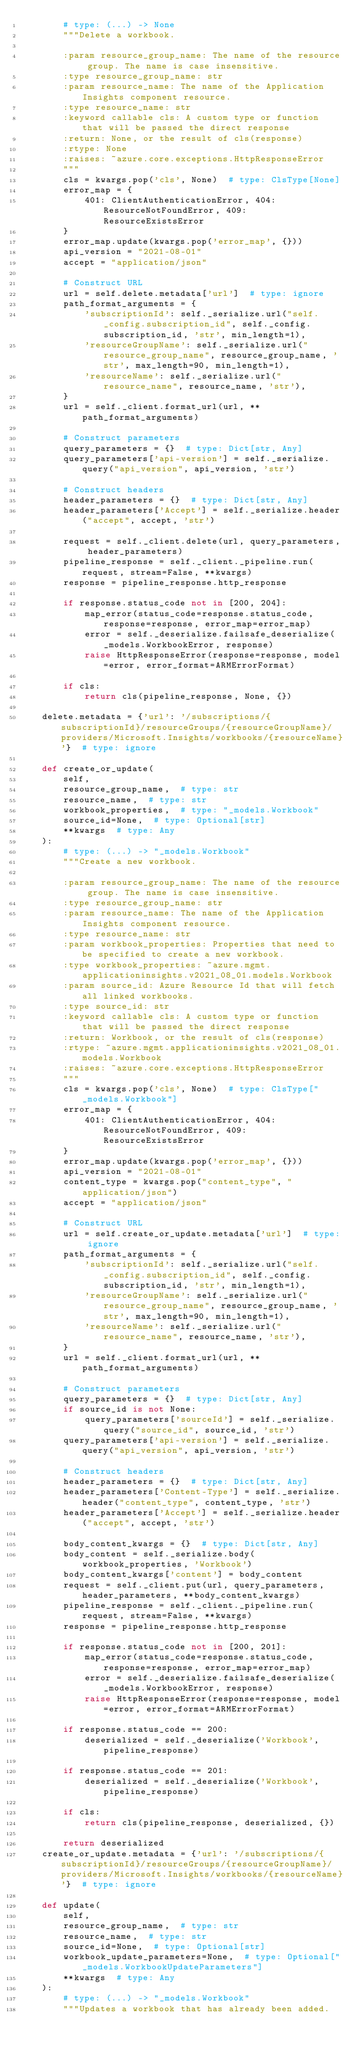Convert code to text. <code><loc_0><loc_0><loc_500><loc_500><_Python_>        # type: (...) -> None
        """Delete a workbook.

        :param resource_group_name: The name of the resource group. The name is case insensitive.
        :type resource_group_name: str
        :param resource_name: The name of the Application Insights component resource.
        :type resource_name: str
        :keyword callable cls: A custom type or function that will be passed the direct response
        :return: None, or the result of cls(response)
        :rtype: None
        :raises: ~azure.core.exceptions.HttpResponseError
        """
        cls = kwargs.pop('cls', None)  # type: ClsType[None]
        error_map = {
            401: ClientAuthenticationError, 404: ResourceNotFoundError, 409: ResourceExistsError
        }
        error_map.update(kwargs.pop('error_map', {}))
        api_version = "2021-08-01"
        accept = "application/json"

        # Construct URL
        url = self.delete.metadata['url']  # type: ignore
        path_format_arguments = {
            'subscriptionId': self._serialize.url("self._config.subscription_id", self._config.subscription_id, 'str', min_length=1),
            'resourceGroupName': self._serialize.url("resource_group_name", resource_group_name, 'str', max_length=90, min_length=1),
            'resourceName': self._serialize.url("resource_name", resource_name, 'str'),
        }
        url = self._client.format_url(url, **path_format_arguments)

        # Construct parameters
        query_parameters = {}  # type: Dict[str, Any]
        query_parameters['api-version'] = self._serialize.query("api_version", api_version, 'str')

        # Construct headers
        header_parameters = {}  # type: Dict[str, Any]
        header_parameters['Accept'] = self._serialize.header("accept", accept, 'str')

        request = self._client.delete(url, query_parameters, header_parameters)
        pipeline_response = self._client._pipeline.run(request, stream=False, **kwargs)
        response = pipeline_response.http_response

        if response.status_code not in [200, 204]:
            map_error(status_code=response.status_code, response=response, error_map=error_map)
            error = self._deserialize.failsafe_deserialize(_models.WorkbookError, response)
            raise HttpResponseError(response=response, model=error, error_format=ARMErrorFormat)

        if cls:
            return cls(pipeline_response, None, {})

    delete.metadata = {'url': '/subscriptions/{subscriptionId}/resourceGroups/{resourceGroupName}/providers/Microsoft.Insights/workbooks/{resourceName}'}  # type: ignore

    def create_or_update(
        self,
        resource_group_name,  # type: str
        resource_name,  # type: str
        workbook_properties,  # type: "_models.Workbook"
        source_id=None,  # type: Optional[str]
        **kwargs  # type: Any
    ):
        # type: (...) -> "_models.Workbook"
        """Create a new workbook.

        :param resource_group_name: The name of the resource group. The name is case insensitive.
        :type resource_group_name: str
        :param resource_name: The name of the Application Insights component resource.
        :type resource_name: str
        :param workbook_properties: Properties that need to be specified to create a new workbook.
        :type workbook_properties: ~azure.mgmt.applicationinsights.v2021_08_01.models.Workbook
        :param source_id: Azure Resource Id that will fetch all linked workbooks.
        :type source_id: str
        :keyword callable cls: A custom type or function that will be passed the direct response
        :return: Workbook, or the result of cls(response)
        :rtype: ~azure.mgmt.applicationinsights.v2021_08_01.models.Workbook
        :raises: ~azure.core.exceptions.HttpResponseError
        """
        cls = kwargs.pop('cls', None)  # type: ClsType["_models.Workbook"]
        error_map = {
            401: ClientAuthenticationError, 404: ResourceNotFoundError, 409: ResourceExistsError
        }
        error_map.update(kwargs.pop('error_map', {}))
        api_version = "2021-08-01"
        content_type = kwargs.pop("content_type", "application/json")
        accept = "application/json"

        # Construct URL
        url = self.create_or_update.metadata['url']  # type: ignore
        path_format_arguments = {
            'subscriptionId': self._serialize.url("self._config.subscription_id", self._config.subscription_id, 'str', min_length=1),
            'resourceGroupName': self._serialize.url("resource_group_name", resource_group_name, 'str', max_length=90, min_length=1),
            'resourceName': self._serialize.url("resource_name", resource_name, 'str'),
        }
        url = self._client.format_url(url, **path_format_arguments)

        # Construct parameters
        query_parameters = {}  # type: Dict[str, Any]
        if source_id is not None:
            query_parameters['sourceId'] = self._serialize.query("source_id", source_id, 'str')
        query_parameters['api-version'] = self._serialize.query("api_version", api_version, 'str')

        # Construct headers
        header_parameters = {}  # type: Dict[str, Any]
        header_parameters['Content-Type'] = self._serialize.header("content_type", content_type, 'str')
        header_parameters['Accept'] = self._serialize.header("accept", accept, 'str')

        body_content_kwargs = {}  # type: Dict[str, Any]
        body_content = self._serialize.body(workbook_properties, 'Workbook')
        body_content_kwargs['content'] = body_content
        request = self._client.put(url, query_parameters, header_parameters, **body_content_kwargs)
        pipeline_response = self._client._pipeline.run(request, stream=False, **kwargs)
        response = pipeline_response.http_response

        if response.status_code not in [200, 201]:
            map_error(status_code=response.status_code, response=response, error_map=error_map)
            error = self._deserialize.failsafe_deserialize(_models.WorkbookError, response)
            raise HttpResponseError(response=response, model=error, error_format=ARMErrorFormat)

        if response.status_code == 200:
            deserialized = self._deserialize('Workbook', pipeline_response)

        if response.status_code == 201:
            deserialized = self._deserialize('Workbook', pipeline_response)

        if cls:
            return cls(pipeline_response, deserialized, {})

        return deserialized
    create_or_update.metadata = {'url': '/subscriptions/{subscriptionId}/resourceGroups/{resourceGroupName}/providers/Microsoft.Insights/workbooks/{resourceName}'}  # type: ignore

    def update(
        self,
        resource_group_name,  # type: str
        resource_name,  # type: str
        source_id=None,  # type: Optional[str]
        workbook_update_parameters=None,  # type: Optional["_models.WorkbookUpdateParameters"]
        **kwargs  # type: Any
    ):
        # type: (...) -> "_models.Workbook"
        """Updates a workbook that has already been added.
</code> 